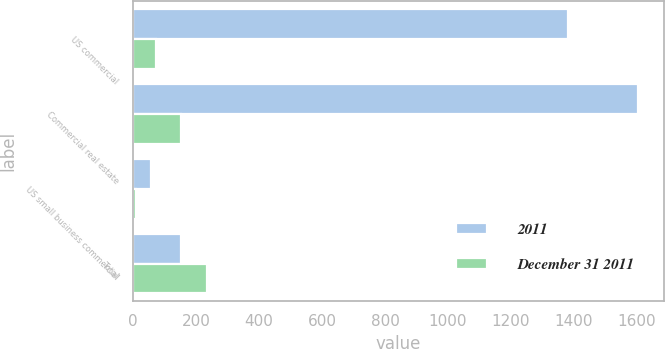Convert chart. <chart><loc_0><loc_0><loc_500><loc_500><stacked_bar_chart><ecel><fcel>US commercial<fcel>Commercial real estate<fcel>US small business commercial<fcel>Total<nl><fcel>2011<fcel>1381<fcel>1604<fcel>58<fcel>152<nl><fcel>December 31 2011<fcel>74<fcel>152<fcel>10<fcel>236<nl></chart> 